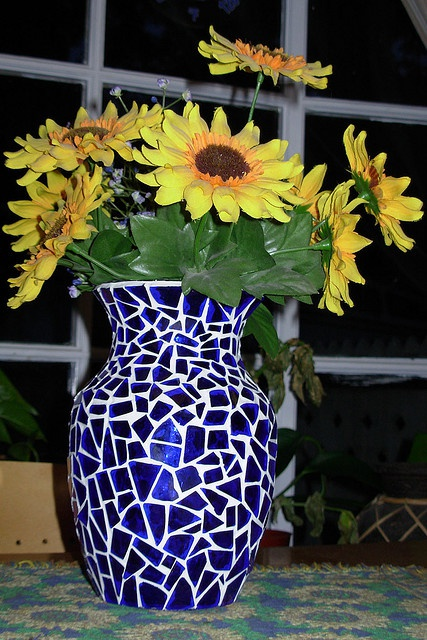Describe the objects in this image and their specific colors. I can see potted plant in black, white, navy, and darkgreen tones and vase in black, white, navy, and darkblue tones in this image. 